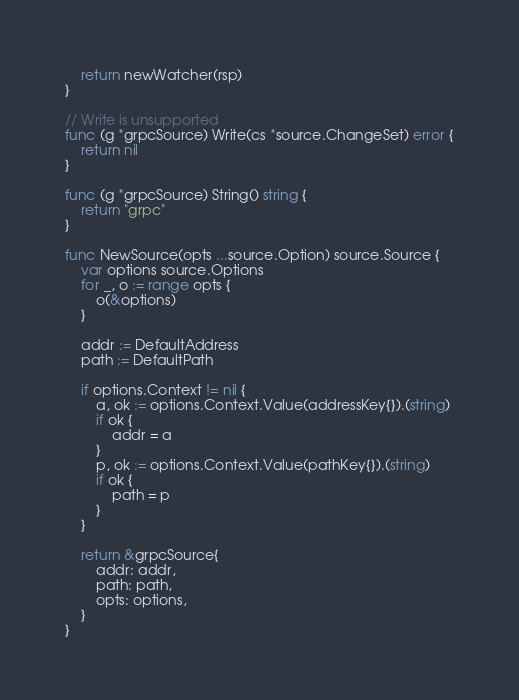<code> <loc_0><loc_0><loc_500><loc_500><_Go_>	return newWatcher(rsp)
}

// Write is unsupported
func (g *grpcSource) Write(cs *source.ChangeSet) error {
	return nil
}

func (g *grpcSource) String() string {
	return "grpc"
}

func NewSource(opts ...source.Option) source.Source {
	var options source.Options
	for _, o := range opts {
		o(&options)
	}

	addr := DefaultAddress
	path := DefaultPath

	if options.Context != nil {
		a, ok := options.Context.Value(addressKey{}).(string)
		if ok {
			addr = a
		}
		p, ok := options.Context.Value(pathKey{}).(string)
		if ok {
			path = p
		}
	}

	return &grpcSource{
		addr: addr,
		path: path,
		opts: options,
	}
}
</code> 